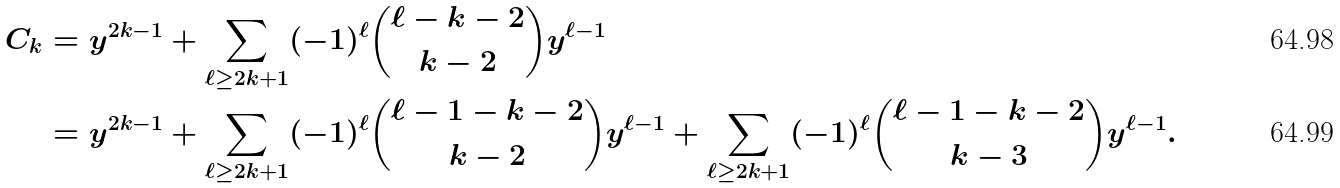<formula> <loc_0><loc_0><loc_500><loc_500>C _ { k } & = y ^ { 2 k - 1 } + \sum _ { \ell \geq 2 k + 1 } ( - 1 ) ^ { \ell } \binom { \ell - k - 2 } { k - 2 } y ^ { \ell - 1 } \\ & = y ^ { 2 k - 1 } + \sum _ { \ell \geq 2 k + 1 } ( - 1 ) ^ { \ell } \binom { \ell - 1 - k - 2 } { k - 2 } y ^ { \ell - 1 } + \sum _ { \ell \geq 2 k + 1 } ( - 1 ) ^ { \ell } \binom { \ell - 1 - k - 2 } { k - 3 } y ^ { \ell - 1 } .</formula> 